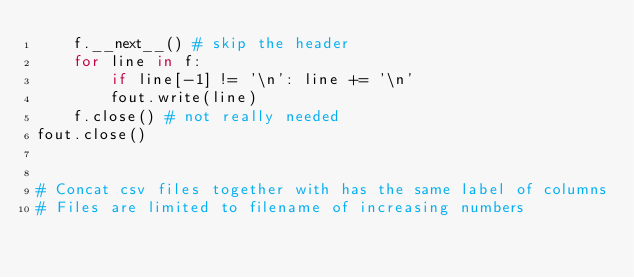Convert code to text. <code><loc_0><loc_0><loc_500><loc_500><_Python_>    f.__next__() # skip the header
    for line in f:
        if line[-1] != '\n': line += '\n'
        fout.write(line)
    f.close() # not really needed
fout.close()


# Concat csv files together with has the same label of columns
# Files are limited to filename of increasing numbers</code> 